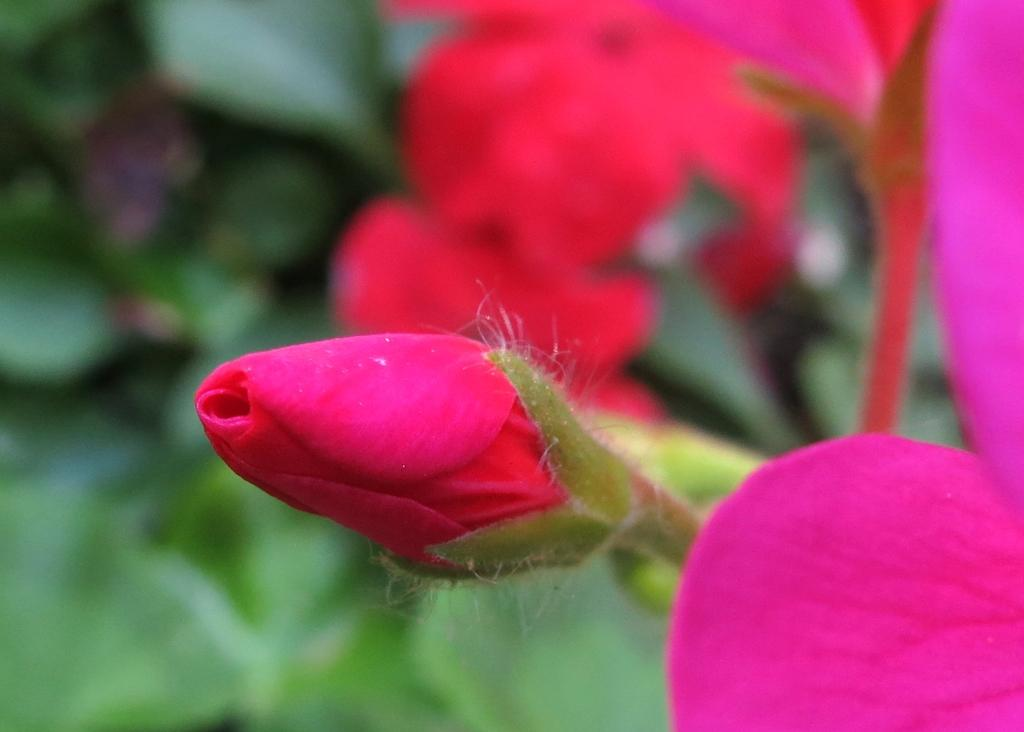What color are the buds and flowers in the image? The buds and flowers in the image are pink. What color is the background of the image? The background of the image is green. How is the background of the image depicted? The background is blurred in the image. Can you see a clam in the image? No, there is no clam present in the image. What type of back is visible in the image? There is no back or person visible in the image; it features pink buds and flowers against a green background. 